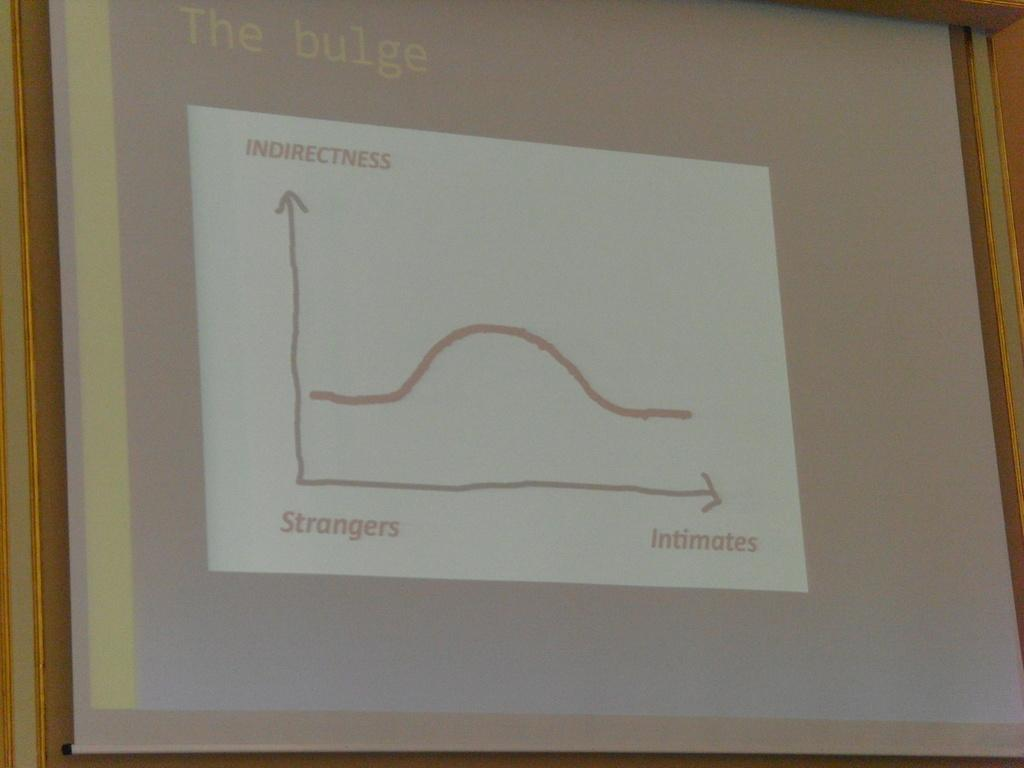<image>
Create a compact narrative representing the image presented. A graph chart that says Strangers, Indirectness and Intimates on it. 